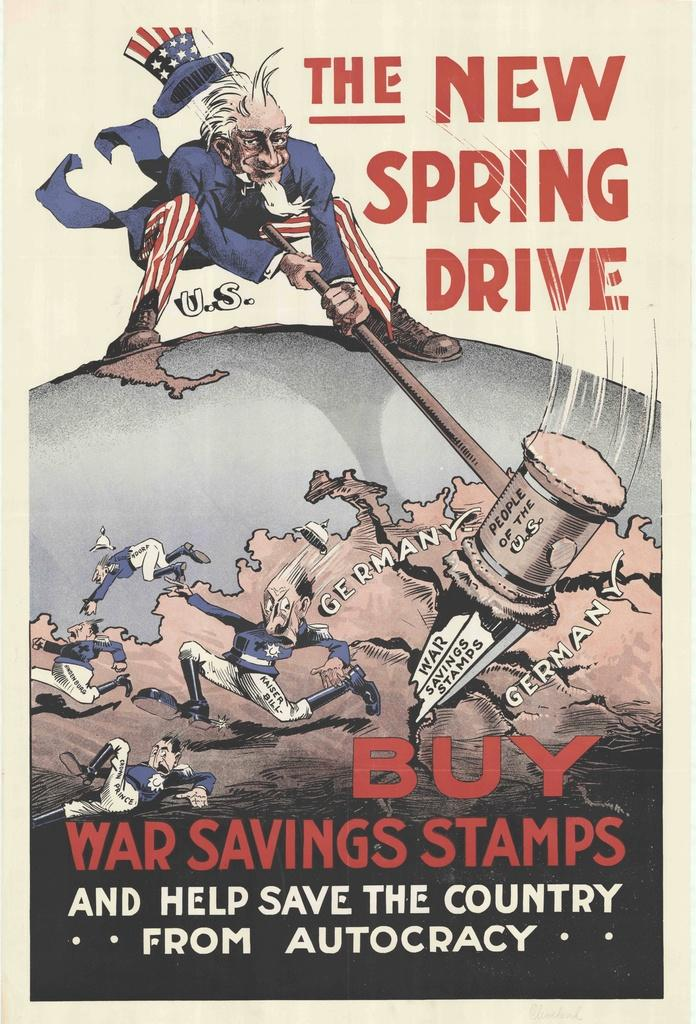<image>
Give a short and clear explanation of the subsequent image. An old advertisement to buy war saving stamps to fund  war. 